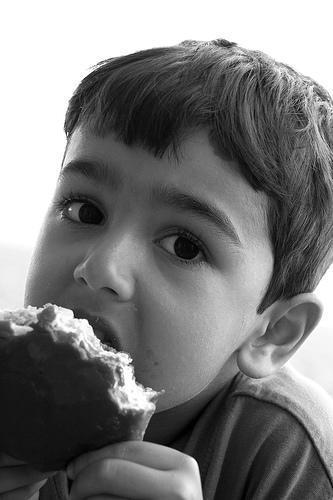How many hands is the boy holding the bread with?
Give a very brief answer. 2. 